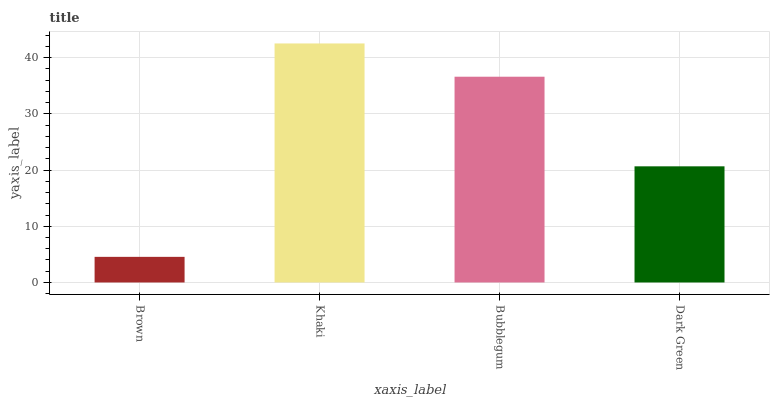Is Bubblegum the minimum?
Answer yes or no. No. Is Bubblegum the maximum?
Answer yes or no. No. Is Khaki greater than Bubblegum?
Answer yes or no. Yes. Is Bubblegum less than Khaki?
Answer yes or no. Yes. Is Bubblegum greater than Khaki?
Answer yes or no. No. Is Khaki less than Bubblegum?
Answer yes or no. No. Is Bubblegum the high median?
Answer yes or no. Yes. Is Dark Green the low median?
Answer yes or no. Yes. Is Dark Green the high median?
Answer yes or no. No. Is Khaki the low median?
Answer yes or no. No. 